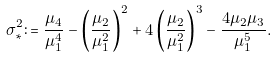Convert formula to latex. <formula><loc_0><loc_0><loc_500><loc_500>\sigma _ { * } ^ { 2 } \colon = \frac { \mu _ { 4 } } { \mu _ { 1 } ^ { 4 } } - \left ( \frac { \mu _ { 2 } } { \mu _ { 1 } ^ { 2 } } \right ) ^ { 2 } + 4 \left ( \frac { \mu _ { 2 } } { \mu _ { 1 } ^ { 2 } } \right ) ^ { 3 } - \frac { 4 \mu _ { 2 } \mu _ { 3 } } { \mu _ { 1 } ^ { 5 } } .</formula> 